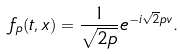Convert formula to latex. <formula><loc_0><loc_0><loc_500><loc_500>f _ { p } ( t , x ) = \frac { 1 } { \sqrt { 2 p } } e ^ { - i \sqrt { 2 } p v } .</formula> 